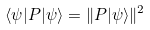<formula> <loc_0><loc_0><loc_500><loc_500>\langle \psi | P | \psi \rangle = \| P | \psi \rangle \| ^ { 2 }</formula> 